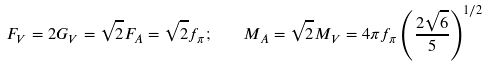Convert formula to latex. <formula><loc_0><loc_0><loc_500><loc_500>F _ { V } = 2 G _ { V } = \sqrt { 2 } F _ { A } = \sqrt { 2 } f _ { \pi } ; \quad M _ { A } = \sqrt { 2 } M _ { V } = 4 \pi f _ { \pi } \left ( \frac { 2 \sqrt { 6 } } { 5 } \right ) ^ { 1 / 2 }</formula> 